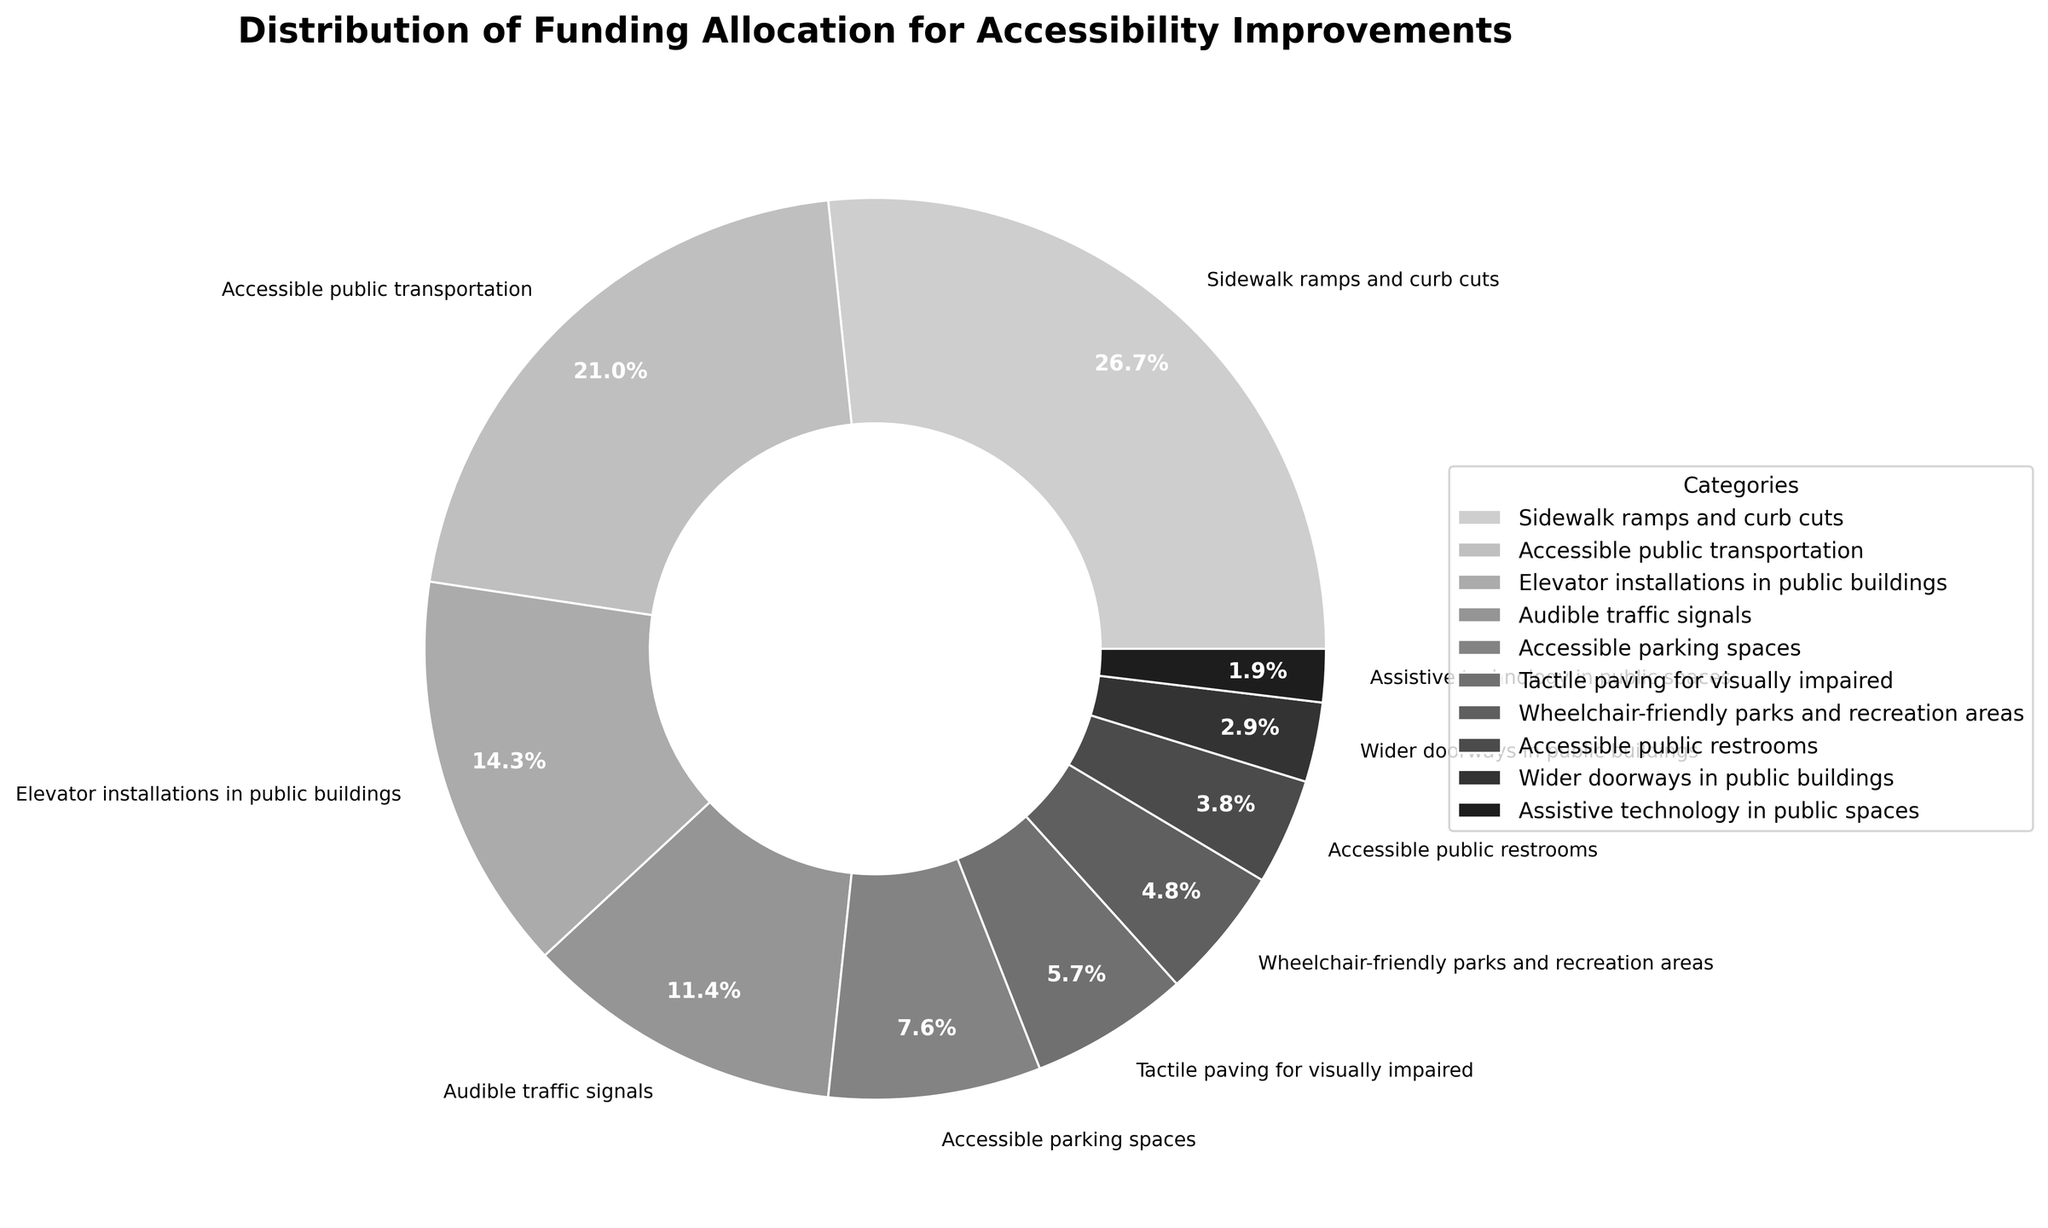What's the largest category in terms of funding allocation? Look at the pie chart and identify the category with the largest slice. "Sidewalk ramps and curb cuts" has the largest slice.
Answer: Sidewalk ramps and curb cuts Which category received the least funding allocation? The smallest slice on the pie chart represents the category with the least funding, which is "Assistive technology in public spaces".
Answer: Assistive technology in public spaces What is the combined funding percentage for "Sidewalk ramps and curb cuts" and "Accessible public transportation"? Add the percentages for "Sidewalk ramps and curb cuts" (28%) and "Accessible public transportation" (22%). 28% + 22% = 50%.
Answer: 50% Is the funding for "Elevator installations in public buildings" greater than for "Audible traffic signals"? Compare the size of the slices for the two categories. The slice for "Elevator installations in public buildings" is larger than that for "Audible traffic signals" since 15% > 12%.
Answer: Yes How much more funding does "Accessible public transportation" receive compared to "Accessible parking spaces"? Subtract the percentage of "Accessible parking spaces" from "Accessible public transportation". 22% - 8% = 14%.
Answer: 14% Do “Tactile paving for visually impaired” and “Audible traffic signals” together constitute more funding than “Elevator installations in public buildings”? Add the percentages for “Tactile paving for visually impaired” (6%) and “Audible traffic signals” (12%) and compare it with “Elevator installations in public buildings” which is 15%. The sum, 6% + 12% = 18%, is more than 15%.
Answer: Yes Which category has a slightly larger share of funding: “Wheelchair-friendly parks and recreation areas” or “Accessible public restrooms”? Compare the slices of "Wheelchair-friendly parks and recreation areas" (5%) and "Accessible public restrooms" (4%). The former has a slightly larger share.
Answer: Wheelchair-friendly parks and recreation areas If the funding for “Wider doorways in public buildings” is doubled, what would be the new percentage? Multiply the current percentage (3%) by 2. 3% * 2 = 6%.
Answer: 6% Out of "Tactile paving for visually impaired" and "Wheelchair-friendly parks and recreation areas", which category receives more funding and by how much? Compare the percentages of the two categories. "Tactile paving for visually impaired" is 6%, and "Wheelchair-friendly parks and recreation areas" is 5%. 6% - 5% = 1%. "Tactile paving for visually impaired" receives 1% more funding.
Answer: Tactile paving for visually impaired by 1% What fraction of the total funding allocation does “Accessible public restrooms” represent? Recognize that the pie chart represents the whole (100%). The percentage for “Accessible public restrooms” is 4%, which translates to the fraction 4/100 or simplified 1/25.
Answer: 1/25 